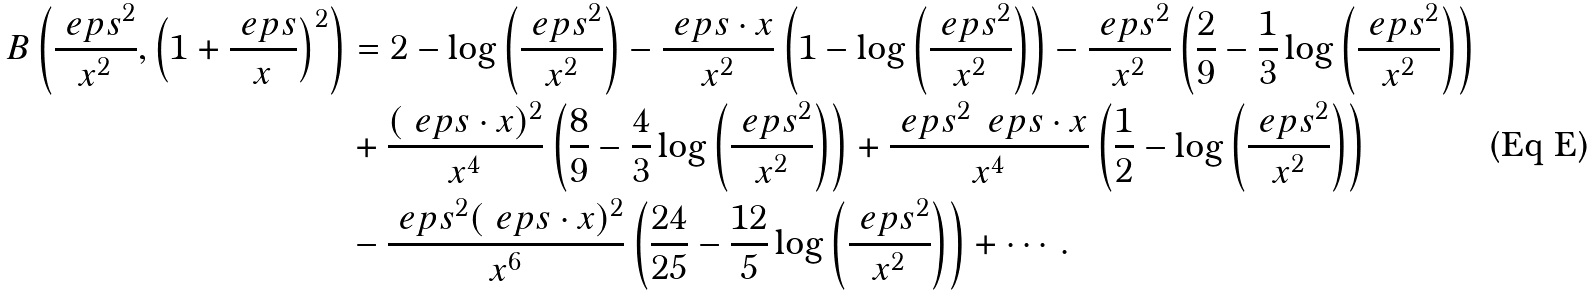Convert formula to latex. <formula><loc_0><loc_0><loc_500><loc_500>B \left ( \frac { \ e p s ^ { 2 } } { x ^ { 2 } } , \left ( 1 + \frac { \ e p s } { x } \right ) ^ { 2 } \right ) & = 2 - \log \left ( \frac { \ e p s ^ { 2 } } { x ^ { 2 } } \right ) - \frac { \ e p s \cdot x } { x ^ { 2 } } \left ( 1 - \log \left ( \frac { \ e p s ^ { 2 } } { x ^ { 2 } } \right ) \right ) - \frac { \ e p s ^ { 2 } } { x ^ { 2 } } \left ( \frac { 2 } { 9 } - \frac { 1 } { 3 } \log \left ( \frac { \ e p s ^ { 2 } } { x ^ { 2 } } \right ) \right ) \\ & + \frac { ( \ e p s \cdot x ) ^ { 2 } } { x ^ { 4 } } \left ( \frac { 8 } { 9 } - \frac { 4 } { 3 } \log \left ( \frac { \ e p s ^ { 2 } } { x ^ { 2 } } \right ) \right ) + \frac { \ e p s ^ { 2 } \, \ e p s \cdot x } { x ^ { 4 } } \left ( \frac { 1 } { 2 } - \log \left ( \frac { \ e p s ^ { 2 } } { x ^ { 2 } } \right ) \right ) \\ & - \frac { \ e p s ^ { 2 } ( \ e p s \cdot x ) ^ { 2 } } { x ^ { 6 } } \left ( \frac { 2 4 } { 2 5 } - \frac { 1 2 } { 5 } \log \left ( \frac { \ e p s ^ { 2 } } { x ^ { 2 } } \right ) \right ) + \cdots \, .</formula> 